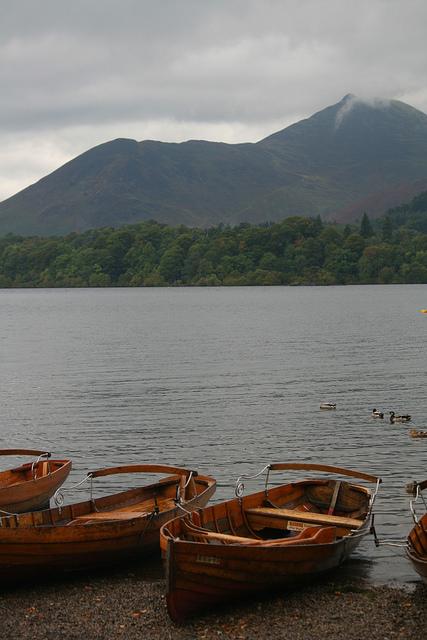Are the boats in the water?
Concise answer only. No. Is it possible these boats are utilized for tourism?
Write a very short answer. Yes. What is beyond the trees?
Answer briefly. Mountains. What color is the boat?
Keep it brief. Brown. What color is the water?
Be succinct. Gray. 